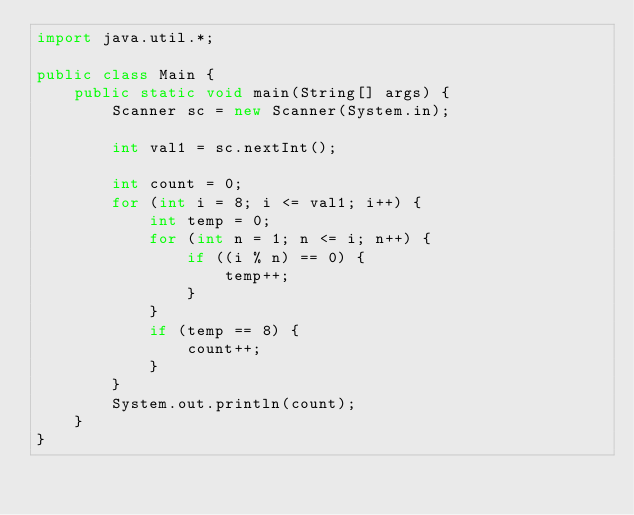Convert code to text. <code><loc_0><loc_0><loc_500><loc_500><_Java_>import java.util.*;

public class Main {
    public static void main(String[] args) {
        Scanner sc = new Scanner(System.in);

        int val1 = sc.nextInt();

        int count = 0;
        for (int i = 8; i <= val1; i++) {
            int temp = 0;
            for (int n = 1; n <= i; n++) {
                if ((i % n) == 0) {
                    temp++;
                }
            }
            if (temp == 8) {
                count++;
            }
        }
        System.out.println(count);
    }
}</code> 